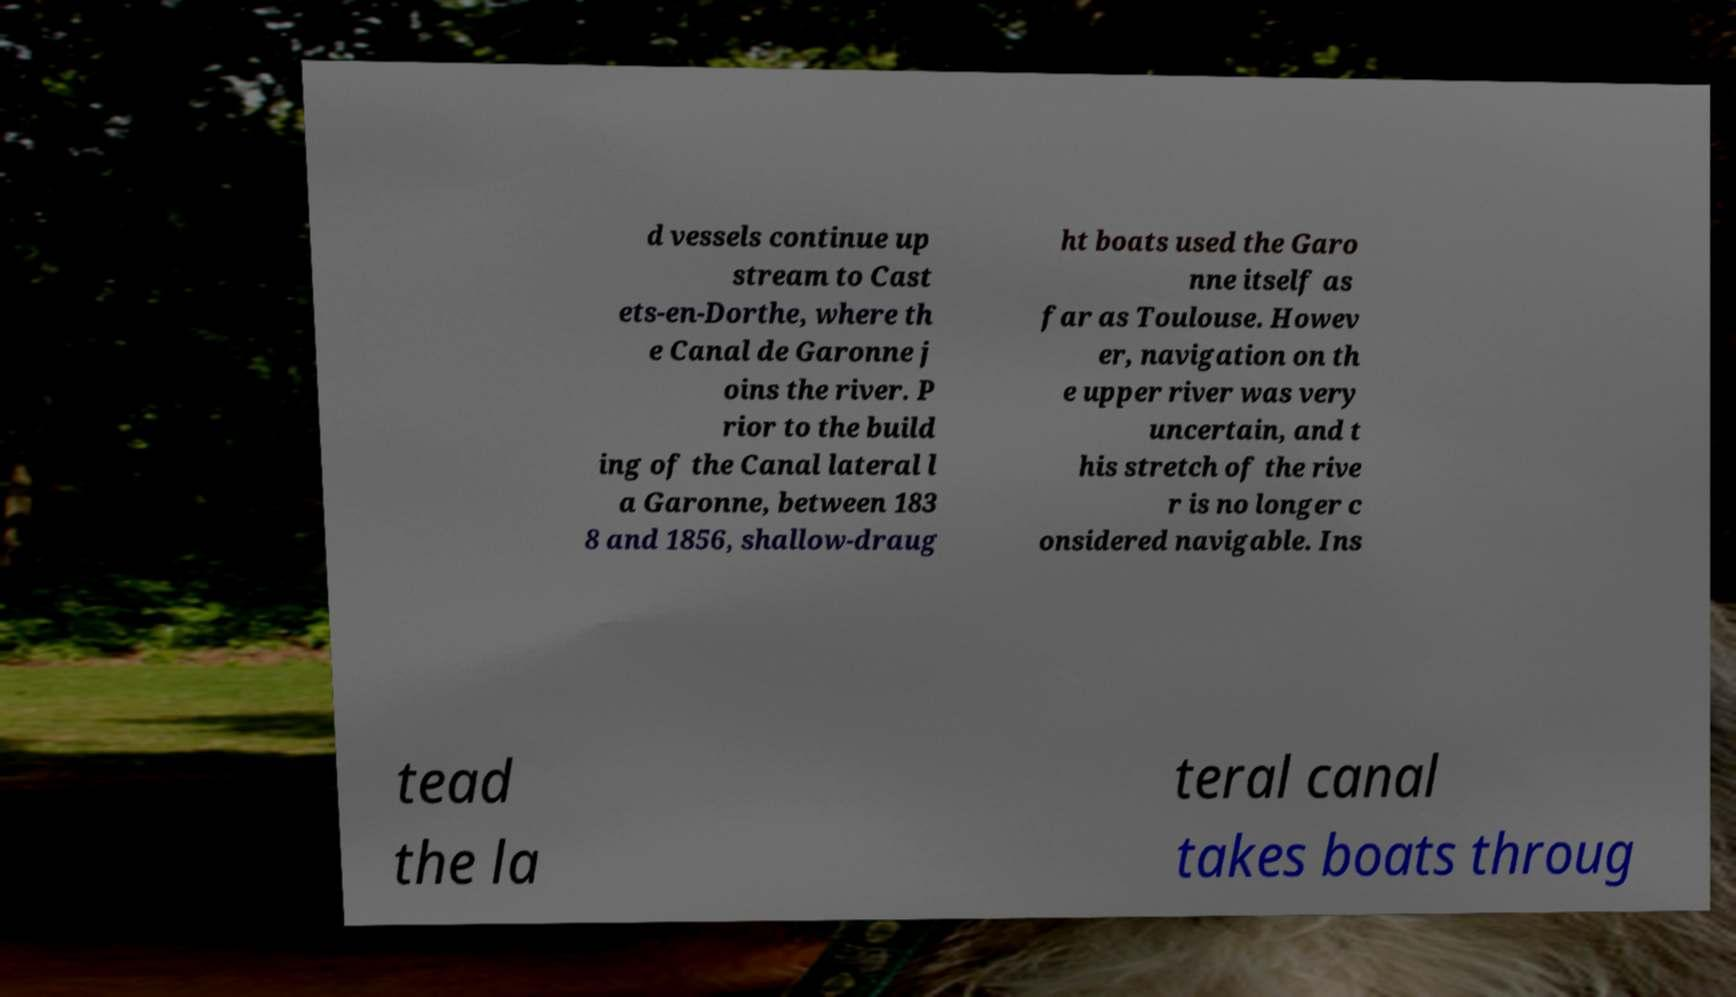Can you read and provide the text displayed in the image?This photo seems to have some interesting text. Can you extract and type it out for me? d vessels continue up stream to Cast ets-en-Dorthe, where th e Canal de Garonne j oins the river. P rior to the build ing of the Canal lateral l a Garonne, between 183 8 and 1856, shallow-draug ht boats used the Garo nne itself as far as Toulouse. Howev er, navigation on th e upper river was very uncertain, and t his stretch of the rive r is no longer c onsidered navigable. Ins tead the la teral canal takes boats throug 